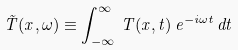<formula> <loc_0><loc_0><loc_500><loc_500>\tilde { T } ( { x } , \omega ) \equiv \int _ { - \infty } ^ { \infty } \, T ( { x } , t ) \, e ^ { - i \omega t } \, d t</formula> 